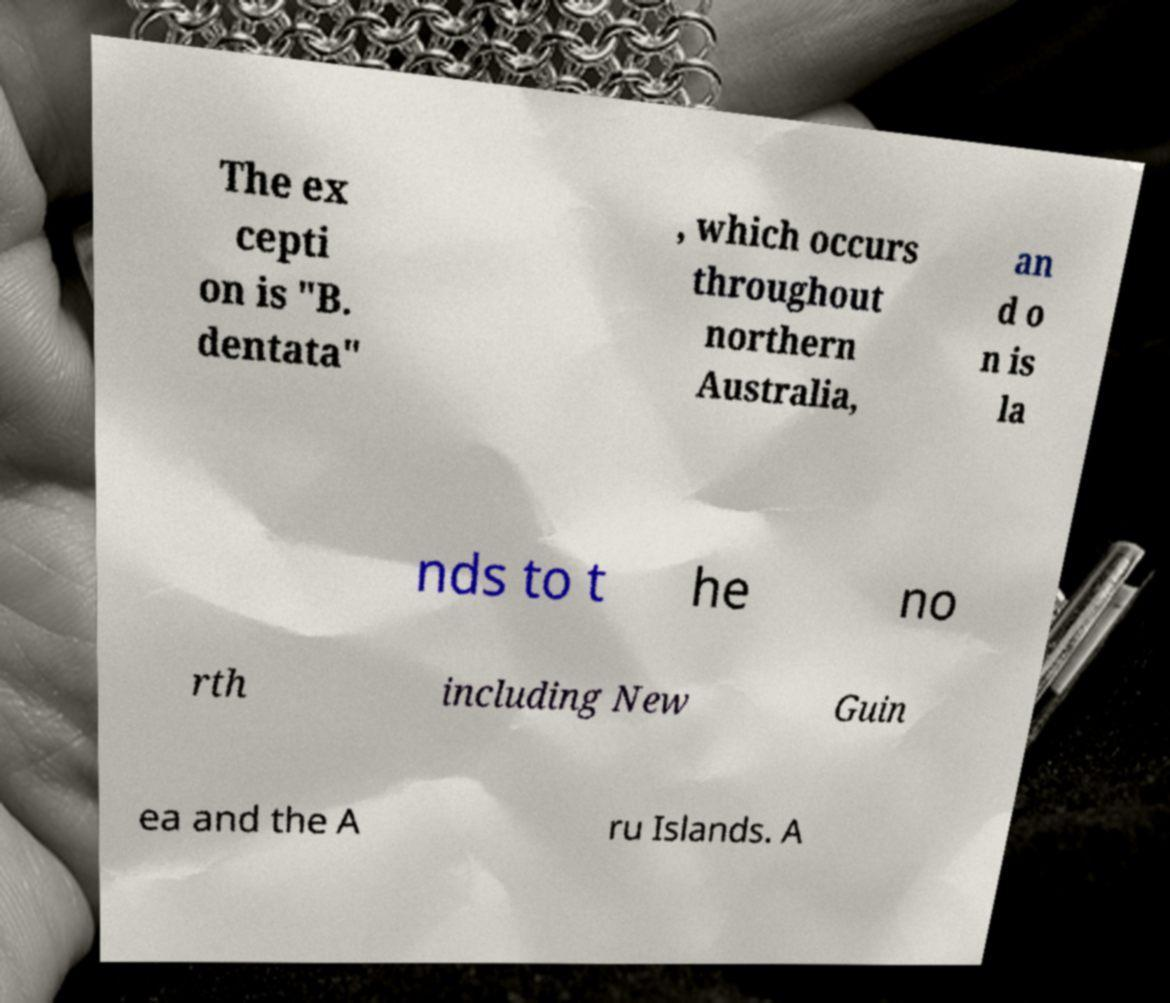Can you read and provide the text displayed in the image?This photo seems to have some interesting text. Can you extract and type it out for me? The ex cepti on is "B. dentata" , which occurs throughout northern Australia, an d o n is la nds to t he no rth including New Guin ea and the A ru Islands. A 